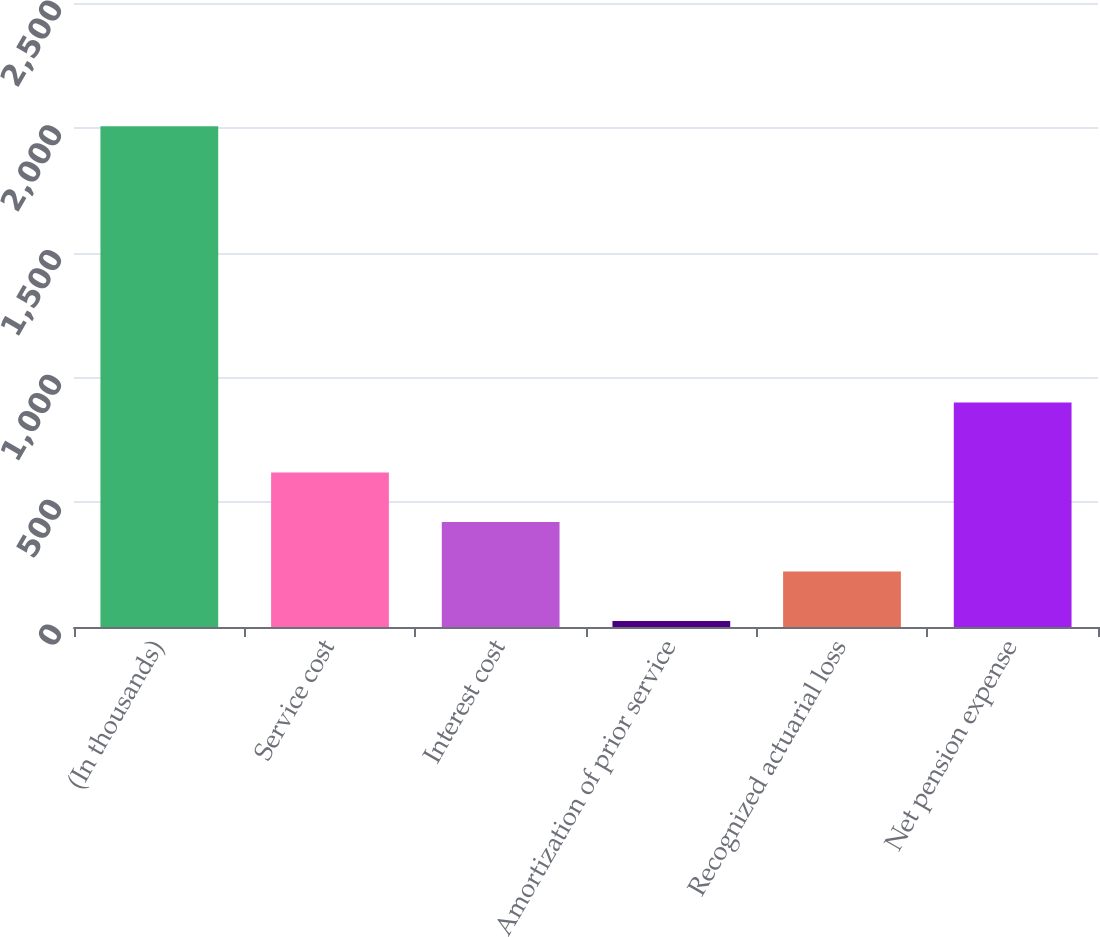Convert chart. <chart><loc_0><loc_0><loc_500><loc_500><bar_chart><fcel>(In thousands)<fcel>Service cost<fcel>Interest cost<fcel>Amortization of prior service<fcel>Recognized actuarial loss<fcel>Net pension expense<nl><fcel>2006<fcel>618.6<fcel>420.4<fcel>24<fcel>222.2<fcel>899<nl></chart> 